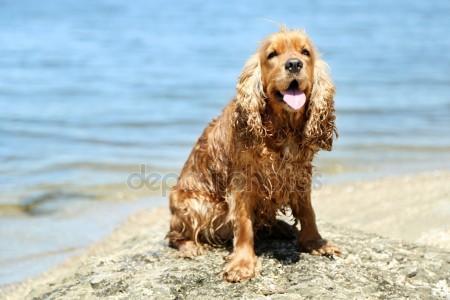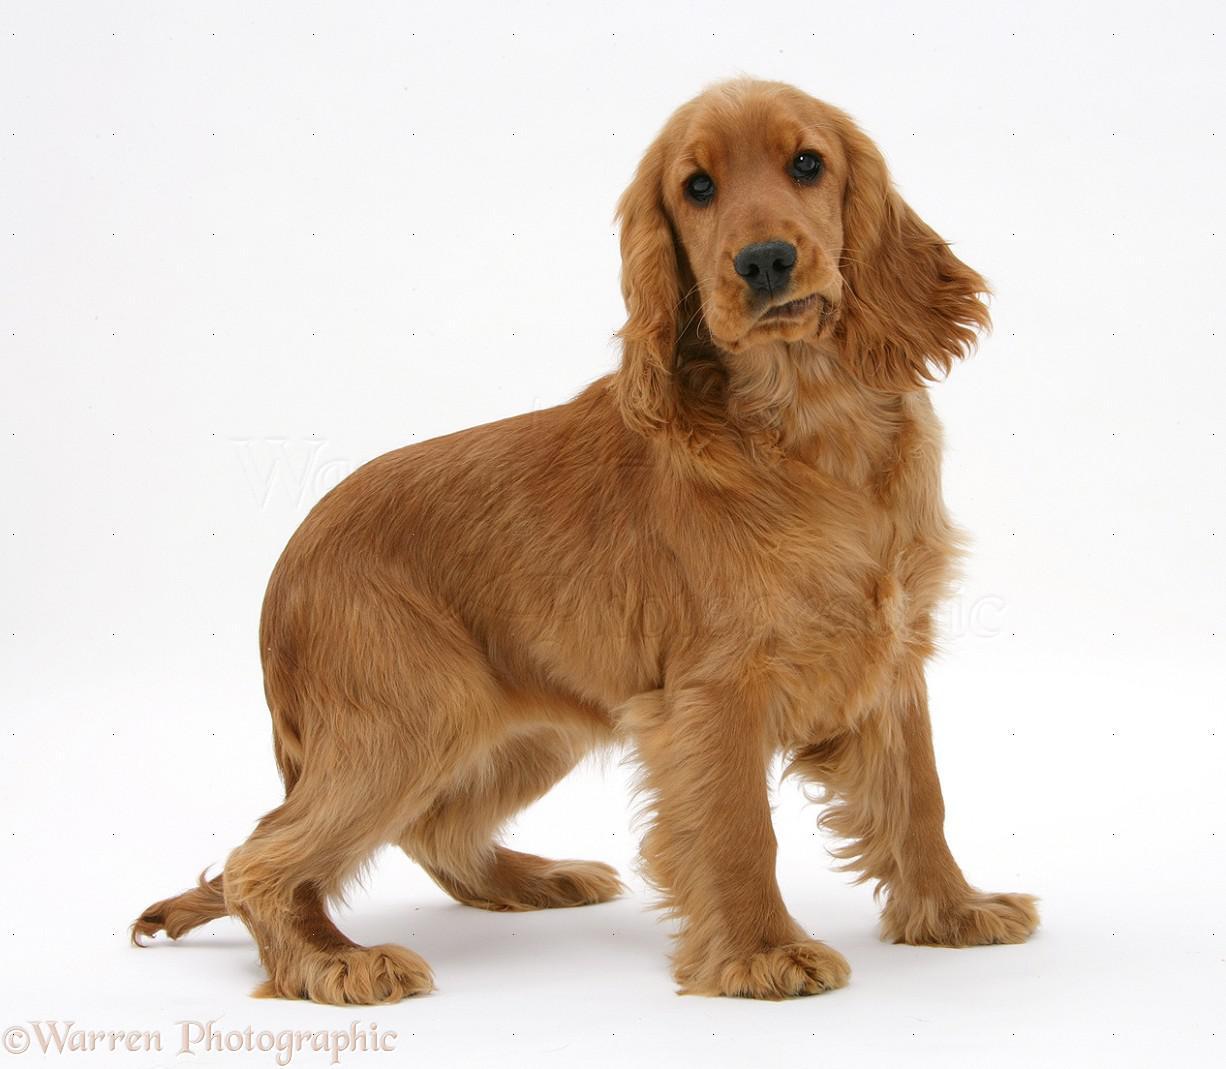The first image is the image on the left, the second image is the image on the right. Analyze the images presented: Is the assertion "An image contains exactly two dogs." valid? Answer yes or no. No. The first image is the image on the left, the second image is the image on the right. Analyze the images presented: Is the assertion "One image contains one forward-facing orange spaniel with wet fur, posed in front of the ocean." valid? Answer yes or no. Yes. 